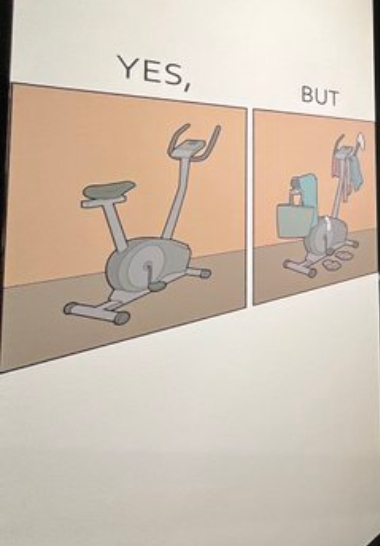Is this image satirical or non-satirical? Yes, this image is satirical. 